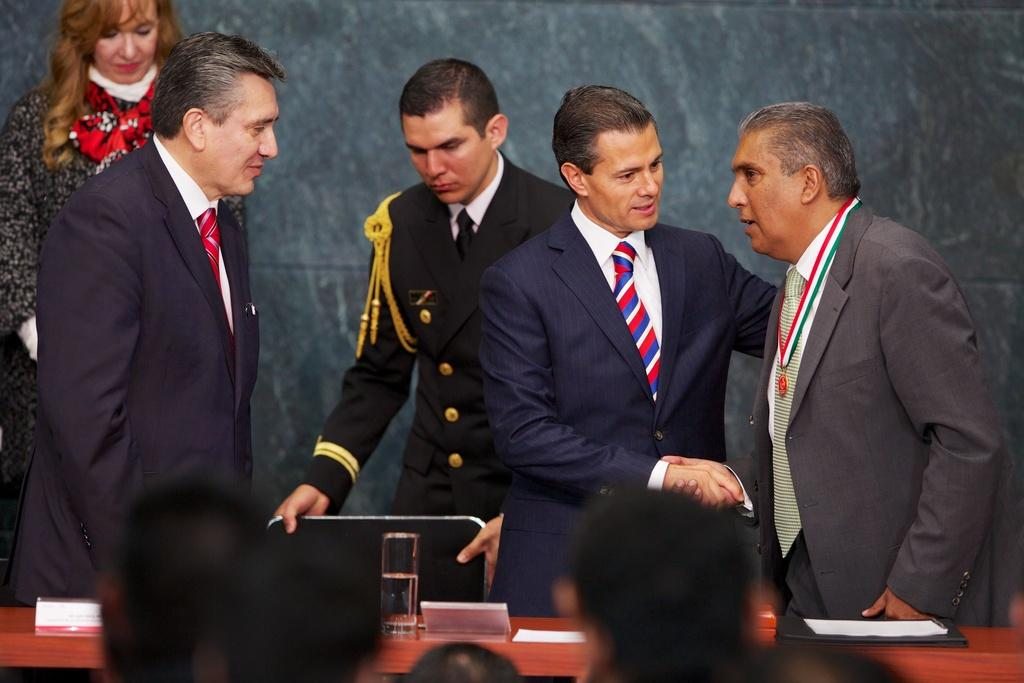How many people are standing in the image? There are four men and a woman standing in the image, making a total of five people. What is in front of the people in the image? There is a table in front of them. What is on the table? There is a glass on the table. Are there any people in front of the table? Yes, there are people standing in front of the table. What type of drink is the zebra holding in the image? There is no zebra present in the image, so it is not possible to determine what, if any, drink it might be holding. 